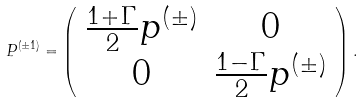Convert formula to latex. <formula><loc_0><loc_0><loc_500><loc_500>P ^ { ( \pm 1 ) } = \left ( \begin{array} { c c } { { \frac { 1 + \Gamma } { 2 } p ^ { ( \pm ) } } } & { 0 } \\ { 0 } & { { \frac { 1 - \Gamma } { 2 } p ^ { ( \pm ) } } } \end{array} \right ) .</formula> 